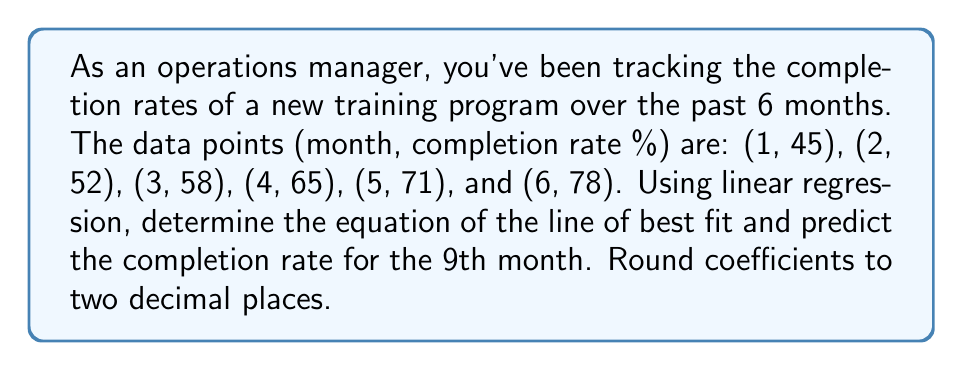Solve this math problem. To solve this problem, we'll use the linear regression formula:

$$ y = mx + b $$

Where $m$ is the slope and $b$ is the y-intercept.

1) First, calculate the means of x and y:
   $\bar{x} = \frac{1+2+3+4+5+6}{6} = 3.5$
   $\bar{y} = \frac{45+52+58+65+71+78}{6} = 61.5$

2) Calculate the slope $m$ using the formula:
   $$ m = \frac{\sum(x_i - \bar{x})(y_i - \bar{y})}{\sum(x_i - \bar{x})^2} $$

   $\sum(x_i - \bar{x})(y_i - \bar{y}) = (-2.5)(-16.5) + (-1.5)(-9.5) + (-0.5)(-3.5) + (0.5)(3.5) + (1.5)(9.5) + (2.5)(16.5) = 192.5$
   
   $\sum(x_i - \bar{x})^2 = (-2.5)^2 + (-1.5)^2 + (-0.5)^2 + (0.5)^2 + (1.5)^2 + (2.5)^2 = 17.5$

   $m = \frac{192.5}{17.5} = 11$

3) Calculate the y-intercept $b$ using the formula:
   $$ b = \bar{y} - m\bar{x} $$
   $b = 61.5 - 11(3.5) = 23$

4) The equation of the line of best fit is:
   $$ y = 11x + 23 $$

5) To predict the completion rate for the 9th month, substitute $x = 9$:
   $y = 11(9) + 23 = 122$

Therefore, the predicted completion rate for the 9th month is 122%.
Answer: The equation of the line of best fit is $y = 11.00x + 23.00$, and the predicted completion rate for the 9th month is 122%. 